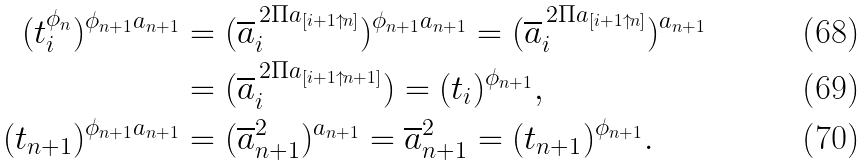<formula> <loc_0><loc_0><loc_500><loc_500>( t ^ { \phi _ { n } } _ { i } ) ^ { \phi _ { n + 1 } a _ { n + 1 } } & = ( \overline { a } _ { i } ^ { \, 2 \Pi a _ { [ i + 1 { \uparrow } n ] } } ) ^ { \phi _ { n + 1 } a _ { n + 1 } } = ( \overline { a } _ { i } ^ { \, 2 \Pi a _ { [ i + 1 { \uparrow } n ] } } ) ^ { a _ { n + 1 } } \\ & = ( \overline { a } _ { i } ^ { \, 2 \Pi a _ { [ i + 1 { \uparrow } n + 1 ] } } ) = ( t _ { i } ) ^ { \phi _ { n + 1 } } , \\ ( t _ { n + 1 } ) ^ { \phi _ { n + 1 } a _ { n + 1 } } & = ( \overline { a } _ { n + 1 } ^ { 2 } ) ^ { a _ { n + 1 } } = \overline { a } _ { n + 1 } ^ { 2 } = ( t _ { n + 1 } ) ^ { \phi _ { n + 1 } } .</formula> 